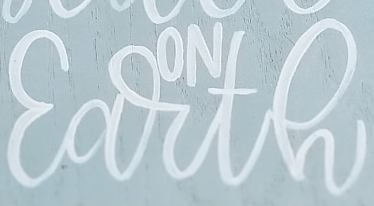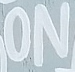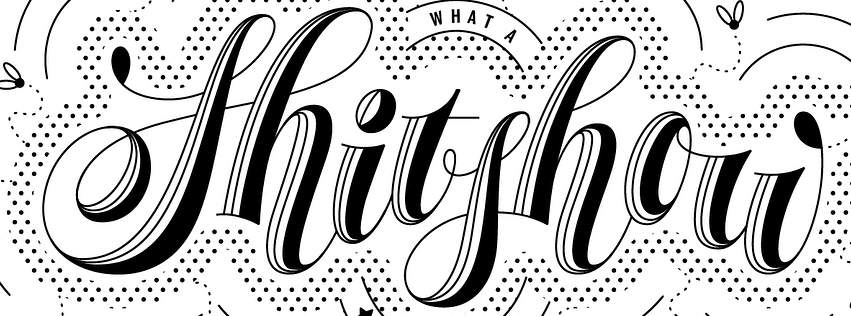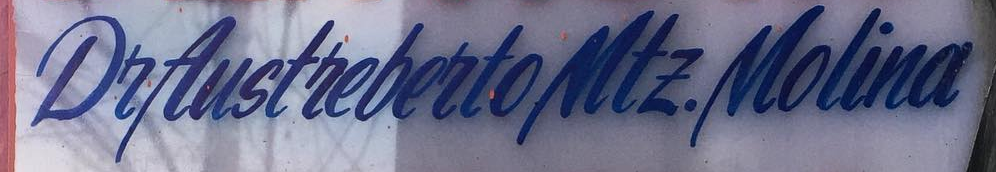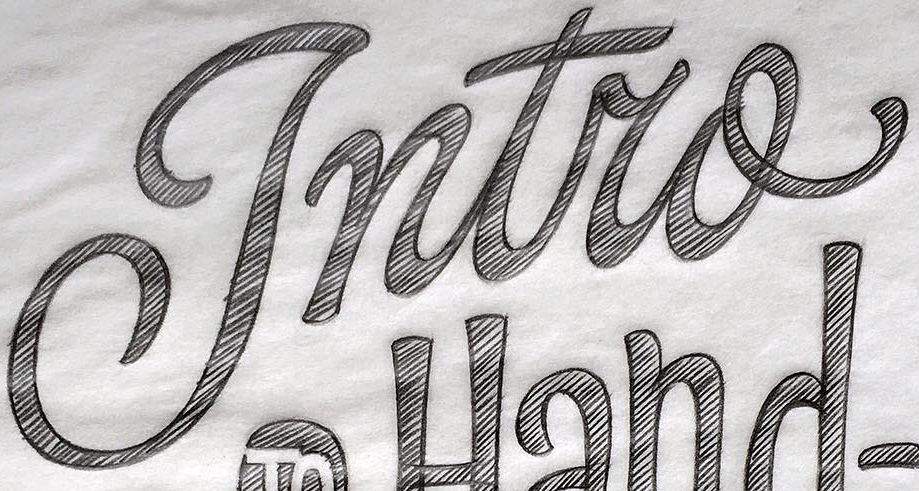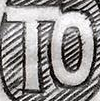Transcribe the words shown in these images in order, separated by a semicolon. Earth; ON; Shitshou; DeAustrebertoMtE.Molina; Intro; TO 